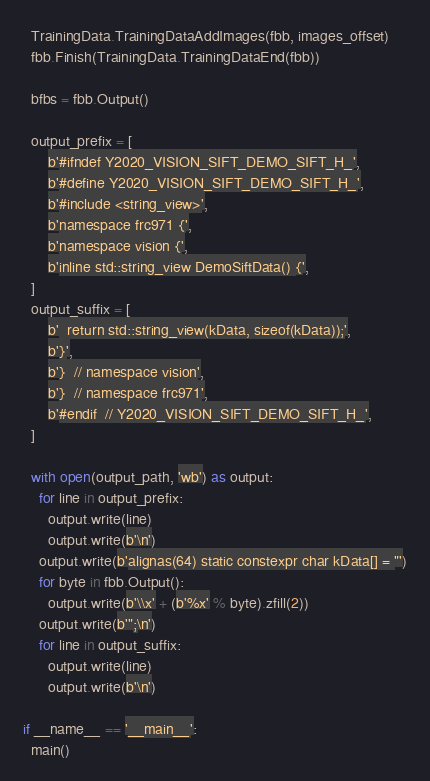<code> <loc_0><loc_0><loc_500><loc_500><_Python_>  TrainingData.TrainingDataAddImages(fbb, images_offset)
  fbb.Finish(TrainingData.TrainingDataEnd(fbb))

  bfbs = fbb.Output()

  output_prefix = [
      b'#ifndef Y2020_VISION_SIFT_DEMO_SIFT_H_',
      b'#define Y2020_VISION_SIFT_DEMO_SIFT_H_',
      b'#include <string_view>',
      b'namespace frc971 {',
      b'namespace vision {',
      b'inline std::string_view DemoSiftData() {',
  ]
  output_suffix = [
      b'  return std::string_view(kData, sizeof(kData));',
      b'}',
      b'}  // namespace vision',
      b'}  // namespace frc971',
      b'#endif  // Y2020_VISION_SIFT_DEMO_SIFT_H_',
  ]

  with open(output_path, 'wb') as output:
    for line in output_prefix:
      output.write(line)
      output.write(b'\n')
    output.write(b'alignas(64) static constexpr char kData[] = "')
    for byte in fbb.Output():
      output.write(b'\\x' + (b'%x' % byte).zfill(2))
    output.write(b'";\n')
    for line in output_suffix:
      output.write(line)
      output.write(b'\n')

if __name__ == '__main__':
  main()
</code> 